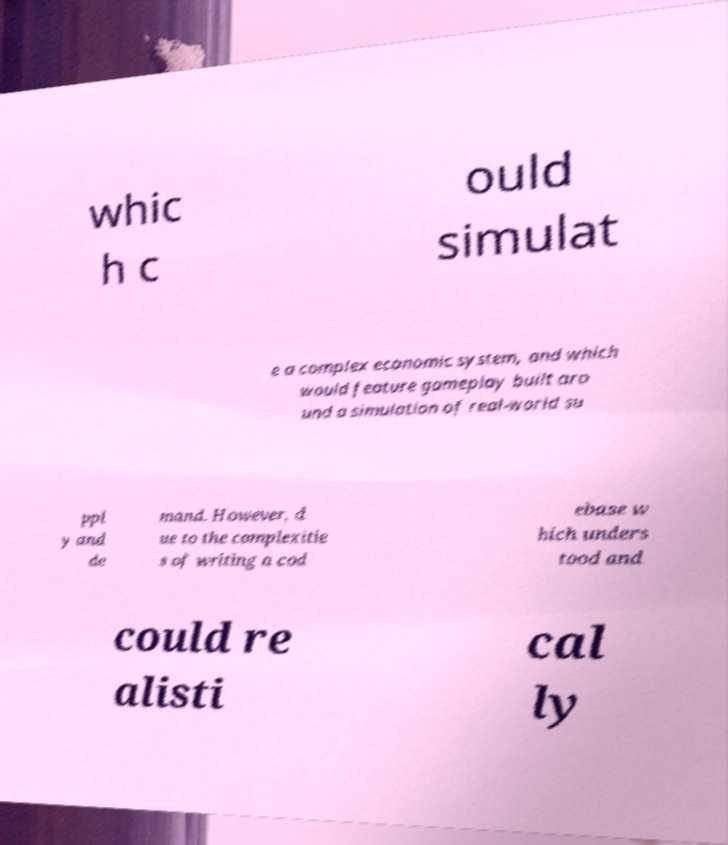Can you accurately transcribe the text from the provided image for me? whic h c ould simulat e a complex economic system, and which would feature gameplay built aro und a simulation of real-world su ppl y and de mand. However, d ue to the complexitie s of writing a cod ebase w hich unders tood and could re alisti cal ly 